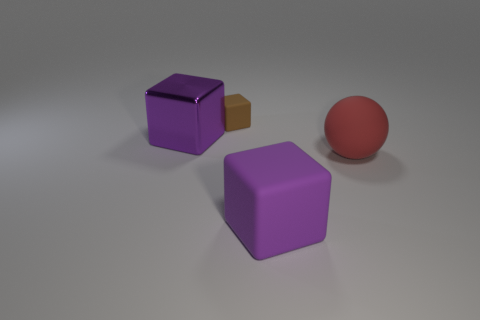Add 1 large purple matte objects. How many objects exist? 5 Subtract all cubes. How many objects are left? 1 Subtract 1 cubes. How many cubes are left? 2 Subtract all gray balls. Subtract all cyan cubes. How many balls are left? 1 Subtract all purple cylinders. How many purple cubes are left? 2 Subtract all small brown things. Subtract all big purple rubber objects. How many objects are left? 2 Add 1 rubber things. How many rubber things are left? 4 Add 1 large balls. How many large balls exist? 2 Subtract all purple cubes. How many cubes are left? 1 Subtract all large matte cubes. How many cubes are left? 2 